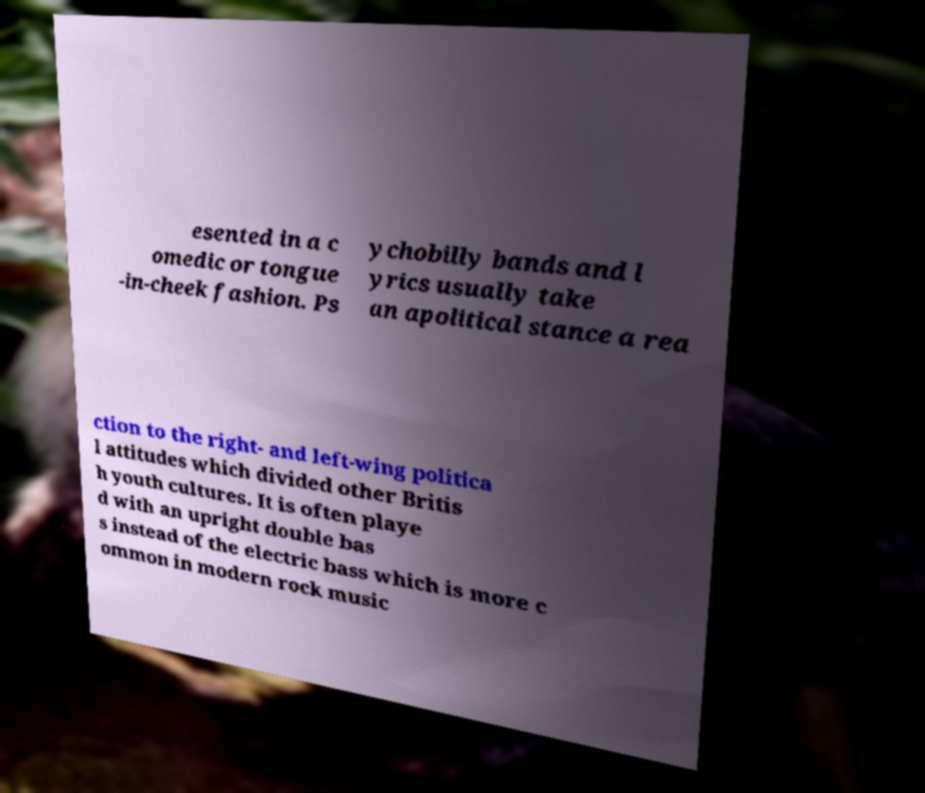Please identify and transcribe the text found in this image. esented in a c omedic or tongue -in-cheek fashion. Ps ychobilly bands and l yrics usually take an apolitical stance a rea ction to the right- and left-wing politica l attitudes which divided other Britis h youth cultures. It is often playe d with an upright double bas s instead of the electric bass which is more c ommon in modern rock music 